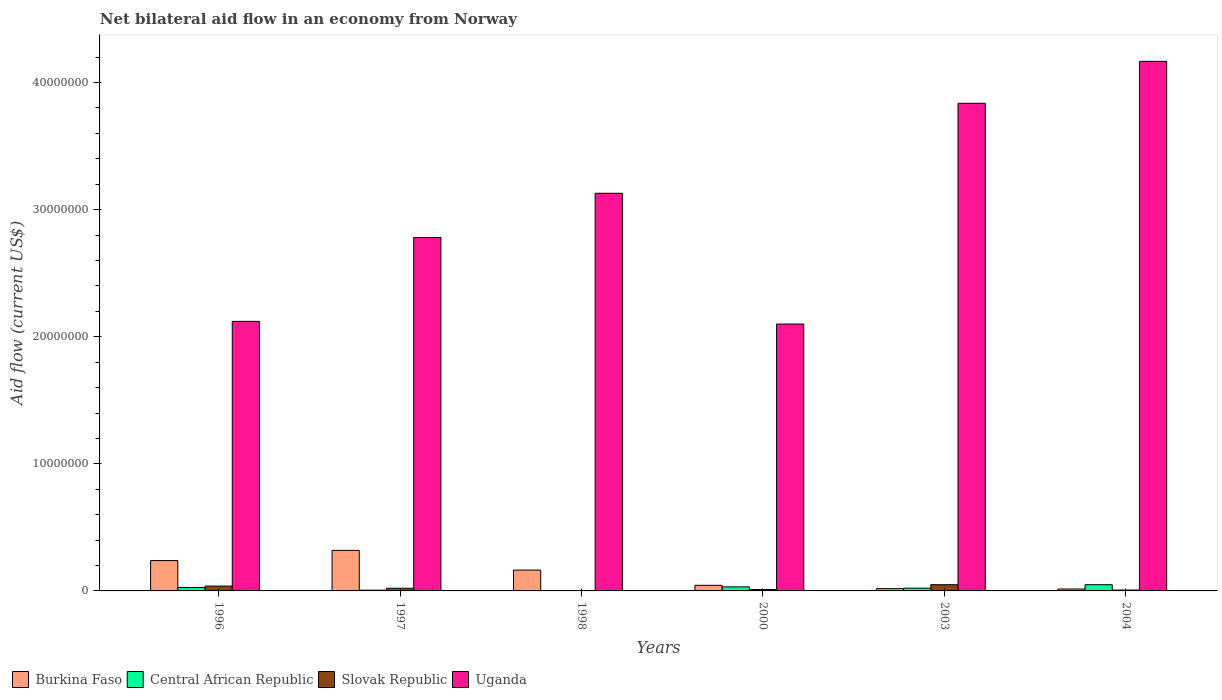How many bars are there on the 5th tick from the left?
Give a very brief answer. 4. What is the net bilateral aid flow in Central African Republic in 1997?
Provide a succinct answer. 6.00e+04. Across all years, what is the maximum net bilateral aid flow in Uganda?
Provide a succinct answer. 4.17e+07. In which year was the net bilateral aid flow in Central African Republic maximum?
Your answer should be very brief. 2004. What is the total net bilateral aid flow in Uganda in the graph?
Provide a succinct answer. 1.81e+08. What is the difference between the net bilateral aid flow in Slovak Republic in 1996 and that in 2003?
Ensure brevity in your answer.  -1.10e+05. What is the average net bilateral aid flow in Uganda per year?
Your answer should be compact. 3.02e+07. In the year 1998, what is the difference between the net bilateral aid flow in Uganda and net bilateral aid flow in Central African Republic?
Offer a terse response. 3.13e+07. In how many years, is the net bilateral aid flow in Central African Republic greater than 6000000 US$?
Your answer should be compact. 0. What is the ratio of the net bilateral aid flow in Uganda in 1997 to that in 2004?
Make the answer very short. 0.67. Is the net bilateral aid flow in Central African Republic in 1996 less than that in 2000?
Ensure brevity in your answer.  Yes. What is the difference between the highest and the lowest net bilateral aid flow in Burkina Faso?
Make the answer very short. 3.04e+06. In how many years, is the net bilateral aid flow in Burkina Faso greater than the average net bilateral aid flow in Burkina Faso taken over all years?
Ensure brevity in your answer.  3. What does the 3rd bar from the left in 1996 represents?
Offer a terse response. Slovak Republic. What does the 3rd bar from the right in 2000 represents?
Offer a terse response. Central African Republic. Are all the bars in the graph horizontal?
Ensure brevity in your answer.  No. What is the difference between two consecutive major ticks on the Y-axis?
Your answer should be compact. 1.00e+07. How many legend labels are there?
Provide a succinct answer. 4. How are the legend labels stacked?
Provide a succinct answer. Horizontal. What is the title of the graph?
Give a very brief answer. Net bilateral aid flow in an economy from Norway. What is the Aid flow (current US$) in Burkina Faso in 1996?
Offer a very short reply. 2.39e+06. What is the Aid flow (current US$) of Uganda in 1996?
Offer a very short reply. 2.12e+07. What is the Aid flow (current US$) of Burkina Faso in 1997?
Keep it short and to the point. 3.19e+06. What is the Aid flow (current US$) of Central African Republic in 1997?
Your answer should be compact. 6.00e+04. What is the Aid flow (current US$) in Uganda in 1997?
Ensure brevity in your answer.  2.78e+07. What is the Aid flow (current US$) in Burkina Faso in 1998?
Make the answer very short. 1.64e+06. What is the Aid flow (current US$) of Central African Republic in 1998?
Offer a very short reply. 2.00e+04. What is the Aid flow (current US$) in Uganda in 1998?
Keep it short and to the point. 3.13e+07. What is the Aid flow (current US$) of Burkina Faso in 2000?
Your response must be concise. 4.40e+05. What is the Aid flow (current US$) of Slovak Republic in 2000?
Make the answer very short. 1.10e+05. What is the Aid flow (current US$) of Uganda in 2000?
Give a very brief answer. 2.10e+07. What is the Aid flow (current US$) of Central African Republic in 2003?
Offer a terse response. 2.20e+05. What is the Aid flow (current US$) in Uganda in 2003?
Your answer should be compact. 3.84e+07. What is the Aid flow (current US$) of Uganda in 2004?
Provide a succinct answer. 4.17e+07. Across all years, what is the maximum Aid flow (current US$) of Burkina Faso?
Provide a short and direct response. 3.19e+06. Across all years, what is the maximum Aid flow (current US$) in Central African Republic?
Offer a terse response. 4.90e+05. Across all years, what is the maximum Aid flow (current US$) of Uganda?
Your response must be concise. 4.17e+07. Across all years, what is the minimum Aid flow (current US$) of Burkina Faso?
Give a very brief answer. 1.50e+05. Across all years, what is the minimum Aid flow (current US$) of Slovak Republic?
Your answer should be compact. 10000. Across all years, what is the minimum Aid flow (current US$) of Uganda?
Your response must be concise. 2.10e+07. What is the total Aid flow (current US$) in Burkina Faso in the graph?
Your response must be concise. 7.99e+06. What is the total Aid flow (current US$) of Central African Republic in the graph?
Make the answer very short. 1.38e+06. What is the total Aid flow (current US$) of Slovak Republic in the graph?
Make the answer very short. 1.27e+06. What is the total Aid flow (current US$) of Uganda in the graph?
Your response must be concise. 1.81e+08. What is the difference between the Aid flow (current US$) of Burkina Faso in 1996 and that in 1997?
Your response must be concise. -8.00e+05. What is the difference between the Aid flow (current US$) of Central African Republic in 1996 and that in 1997?
Your answer should be very brief. 2.10e+05. What is the difference between the Aid flow (current US$) in Slovak Republic in 1996 and that in 1997?
Offer a very short reply. 1.70e+05. What is the difference between the Aid flow (current US$) of Uganda in 1996 and that in 1997?
Give a very brief answer. -6.60e+06. What is the difference between the Aid flow (current US$) of Burkina Faso in 1996 and that in 1998?
Make the answer very short. 7.50e+05. What is the difference between the Aid flow (current US$) of Central African Republic in 1996 and that in 1998?
Keep it short and to the point. 2.50e+05. What is the difference between the Aid flow (current US$) in Slovak Republic in 1996 and that in 1998?
Offer a very short reply. 3.70e+05. What is the difference between the Aid flow (current US$) of Uganda in 1996 and that in 1998?
Offer a terse response. -1.01e+07. What is the difference between the Aid flow (current US$) of Burkina Faso in 1996 and that in 2000?
Make the answer very short. 1.95e+06. What is the difference between the Aid flow (current US$) in Central African Republic in 1996 and that in 2000?
Your answer should be very brief. -5.00e+04. What is the difference between the Aid flow (current US$) of Slovak Republic in 1996 and that in 2000?
Your answer should be compact. 2.70e+05. What is the difference between the Aid flow (current US$) of Burkina Faso in 1996 and that in 2003?
Offer a very short reply. 2.21e+06. What is the difference between the Aid flow (current US$) in Central African Republic in 1996 and that in 2003?
Make the answer very short. 5.00e+04. What is the difference between the Aid flow (current US$) of Slovak Republic in 1996 and that in 2003?
Keep it short and to the point. -1.10e+05. What is the difference between the Aid flow (current US$) in Uganda in 1996 and that in 2003?
Give a very brief answer. -1.72e+07. What is the difference between the Aid flow (current US$) in Burkina Faso in 1996 and that in 2004?
Your answer should be very brief. 2.24e+06. What is the difference between the Aid flow (current US$) in Central African Republic in 1996 and that in 2004?
Your answer should be very brief. -2.20e+05. What is the difference between the Aid flow (current US$) in Uganda in 1996 and that in 2004?
Your response must be concise. -2.05e+07. What is the difference between the Aid flow (current US$) in Burkina Faso in 1997 and that in 1998?
Your answer should be very brief. 1.55e+06. What is the difference between the Aid flow (current US$) of Central African Republic in 1997 and that in 1998?
Provide a short and direct response. 4.00e+04. What is the difference between the Aid flow (current US$) in Uganda in 1997 and that in 1998?
Provide a short and direct response. -3.48e+06. What is the difference between the Aid flow (current US$) in Burkina Faso in 1997 and that in 2000?
Ensure brevity in your answer.  2.75e+06. What is the difference between the Aid flow (current US$) of Central African Republic in 1997 and that in 2000?
Offer a terse response. -2.60e+05. What is the difference between the Aid flow (current US$) of Slovak Republic in 1997 and that in 2000?
Provide a short and direct response. 1.00e+05. What is the difference between the Aid flow (current US$) of Uganda in 1997 and that in 2000?
Your answer should be compact. 6.81e+06. What is the difference between the Aid flow (current US$) of Burkina Faso in 1997 and that in 2003?
Make the answer very short. 3.01e+06. What is the difference between the Aid flow (current US$) of Slovak Republic in 1997 and that in 2003?
Offer a very short reply. -2.80e+05. What is the difference between the Aid flow (current US$) in Uganda in 1997 and that in 2003?
Provide a short and direct response. -1.06e+07. What is the difference between the Aid flow (current US$) of Burkina Faso in 1997 and that in 2004?
Keep it short and to the point. 3.04e+06. What is the difference between the Aid flow (current US$) of Central African Republic in 1997 and that in 2004?
Ensure brevity in your answer.  -4.30e+05. What is the difference between the Aid flow (current US$) of Slovak Republic in 1997 and that in 2004?
Offer a terse response. 1.40e+05. What is the difference between the Aid flow (current US$) of Uganda in 1997 and that in 2004?
Offer a very short reply. -1.39e+07. What is the difference between the Aid flow (current US$) of Burkina Faso in 1998 and that in 2000?
Offer a terse response. 1.20e+06. What is the difference between the Aid flow (current US$) of Central African Republic in 1998 and that in 2000?
Offer a very short reply. -3.00e+05. What is the difference between the Aid flow (current US$) of Slovak Republic in 1998 and that in 2000?
Ensure brevity in your answer.  -1.00e+05. What is the difference between the Aid flow (current US$) of Uganda in 1998 and that in 2000?
Ensure brevity in your answer.  1.03e+07. What is the difference between the Aid flow (current US$) of Burkina Faso in 1998 and that in 2003?
Provide a short and direct response. 1.46e+06. What is the difference between the Aid flow (current US$) of Central African Republic in 1998 and that in 2003?
Your answer should be very brief. -2.00e+05. What is the difference between the Aid flow (current US$) of Slovak Republic in 1998 and that in 2003?
Provide a short and direct response. -4.80e+05. What is the difference between the Aid flow (current US$) of Uganda in 1998 and that in 2003?
Provide a succinct answer. -7.08e+06. What is the difference between the Aid flow (current US$) of Burkina Faso in 1998 and that in 2004?
Your answer should be compact. 1.49e+06. What is the difference between the Aid flow (current US$) of Central African Republic in 1998 and that in 2004?
Your response must be concise. -4.70e+05. What is the difference between the Aid flow (current US$) of Uganda in 1998 and that in 2004?
Your response must be concise. -1.04e+07. What is the difference between the Aid flow (current US$) in Slovak Republic in 2000 and that in 2003?
Offer a terse response. -3.80e+05. What is the difference between the Aid flow (current US$) in Uganda in 2000 and that in 2003?
Your response must be concise. -1.74e+07. What is the difference between the Aid flow (current US$) of Central African Republic in 2000 and that in 2004?
Give a very brief answer. -1.70e+05. What is the difference between the Aid flow (current US$) in Uganda in 2000 and that in 2004?
Keep it short and to the point. -2.07e+07. What is the difference between the Aid flow (current US$) of Burkina Faso in 2003 and that in 2004?
Ensure brevity in your answer.  3.00e+04. What is the difference between the Aid flow (current US$) in Uganda in 2003 and that in 2004?
Your answer should be very brief. -3.30e+06. What is the difference between the Aid flow (current US$) in Burkina Faso in 1996 and the Aid flow (current US$) in Central African Republic in 1997?
Ensure brevity in your answer.  2.33e+06. What is the difference between the Aid flow (current US$) of Burkina Faso in 1996 and the Aid flow (current US$) of Slovak Republic in 1997?
Provide a succinct answer. 2.18e+06. What is the difference between the Aid flow (current US$) in Burkina Faso in 1996 and the Aid flow (current US$) in Uganda in 1997?
Give a very brief answer. -2.54e+07. What is the difference between the Aid flow (current US$) of Central African Republic in 1996 and the Aid flow (current US$) of Slovak Republic in 1997?
Ensure brevity in your answer.  6.00e+04. What is the difference between the Aid flow (current US$) in Central African Republic in 1996 and the Aid flow (current US$) in Uganda in 1997?
Make the answer very short. -2.75e+07. What is the difference between the Aid flow (current US$) of Slovak Republic in 1996 and the Aid flow (current US$) of Uganda in 1997?
Make the answer very short. -2.74e+07. What is the difference between the Aid flow (current US$) in Burkina Faso in 1996 and the Aid flow (current US$) in Central African Republic in 1998?
Give a very brief answer. 2.37e+06. What is the difference between the Aid flow (current US$) of Burkina Faso in 1996 and the Aid flow (current US$) of Slovak Republic in 1998?
Give a very brief answer. 2.38e+06. What is the difference between the Aid flow (current US$) of Burkina Faso in 1996 and the Aid flow (current US$) of Uganda in 1998?
Give a very brief answer. -2.89e+07. What is the difference between the Aid flow (current US$) of Central African Republic in 1996 and the Aid flow (current US$) of Uganda in 1998?
Your answer should be compact. -3.10e+07. What is the difference between the Aid flow (current US$) in Slovak Republic in 1996 and the Aid flow (current US$) in Uganda in 1998?
Your answer should be compact. -3.09e+07. What is the difference between the Aid flow (current US$) in Burkina Faso in 1996 and the Aid flow (current US$) in Central African Republic in 2000?
Ensure brevity in your answer.  2.07e+06. What is the difference between the Aid flow (current US$) of Burkina Faso in 1996 and the Aid flow (current US$) of Slovak Republic in 2000?
Keep it short and to the point. 2.28e+06. What is the difference between the Aid flow (current US$) in Burkina Faso in 1996 and the Aid flow (current US$) in Uganda in 2000?
Your response must be concise. -1.86e+07. What is the difference between the Aid flow (current US$) of Central African Republic in 1996 and the Aid flow (current US$) of Slovak Republic in 2000?
Provide a short and direct response. 1.60e+05. What is the difference between the Aid flow (current US$) in Central African Republic in 1996 and the Aid flow (current US$) in Uganda in 2000?
Keep it short and to the point. -2.07e+07. What is the difference between the Aid flow (current US$) of Slovak Republic in 1996 and the Aid flow (current US$) of Uganda in 2000?
Offer a terse response. -2.06e+07. What is the difference between the Aid flow (current US$) in Burkina Faso in 1996 and the Aid flow (current US$) in Central African Republic in 2003?
Make the answer very short. 2.17e+06. What is the difference between the Aid flow (current US$) of Burkina Faso in 1996 and the Aid flow (current US$) of Slovak Republic in 2003?
Keep it short and to the point. 1.90e+06. What is the difference between the Aid flow (current US$) of Burkina Faso in 1996 and the Aid flow (current US$) of Uganda in 2003?
Ensure brevity in your answer.  -3.60e+07. What is the difference between the Aid flow (current US$) of Central African Republic in 1996 and the Aid flow (current US$) of Uganda in 2003?
Your response must be concise. -3.81e+07. What is the difference between the Aid flow (current US$) of Slovak Republic in 1996 and the Aid flow (current US$) of Uganda in 2003?
Make the answer very short. -3.80e+07. What is the difference between the Aid flow (current US$) in Burkina Faso in 1996 and the Aid flow (current US$) in Central African Republic in 2004?
Provide a succinct answer. 1.90e+06. What is the difference between the Aid flow (current US$) of Burkina Faso in 1996 and the Aid flow (current US$) of Slovak Republic in 2004?
Your answer should be very brief. 2.32e+06. What is the difference between the Aid flow (current US$) of Burkina Faso in 1996 and the Aid flow (current US$) of Uganda in 2004?
Your answer should be very brief. -3.93e+07. What is the difference between the Aid flow (current US$) of Central African Republic in 1996 and the Aid flow (current US$) of Slovak Republic in 2004?
Give a very brief answer. 2.00e+05. What is the difference between the Aid flow (current US$) in Central African Republic in 1996 and the Aid flow (current US$) in Uganda in 2004?
Ensure brevity in your answer.  -4.14e+07. What is the difference between the Aid flow (current US$) in Slovak Republic in 1996 and the Aid flow (current US$) in Uganda in 2004?
Provide a short and direct response. -4.13e+07. What is the difference between the Aid flow (current US$) of Burkina Faso in 1997 and the Aid flow (current US$) of Central African Republic in 1998?
Your response must be concise. 3.17e+06. What is the difference between the Aid flow (current US$) of Burkina Faso in 1997 and the Aid flow (current US$) of Slovak Republic in 1998?
Keep it short and to the point. 3.18e+06. What is the difference between the Aid flow (current US$) in Burkina Faso in 1997 and the Aid flow (current US$) in Uganda in 1998?
Give a very brief answer. -2.81e+07. What is the difference between the Aid flow (current US$) of Central African Republic in 1997 and the Aid flow (current US$) of Slovak Republic in 1998?
Ensure brevity in your answer.  5.00e+04. What is the difference between the Aid flow (current US$) in Central African Republic in 1997 and the Aid flow (current US$) in Uganda in 1998?
Your answer should be very brief. -3.12e+07. What is the difference between the Aid flow (current US$) in Slovak Republic in 1997 and the Aid flow (current US$) in Uganda in 1998?
Make the answer very short. -3.11e+07. What is the difference between the Aid flow (current US$) in Burkina Faso in 1997 and the Aid flow (current US$) in Central African Republic in 2000?
Your answer should be very brief. 2.87e+06. What is the difference between the Aid flow (current US$) of Burkina Faso in 1997 and the Aid flow (current US$) of Slovak Republic in 2000?
Your answer should be very brief. 3.08e+06. What is the difference between the Aid flow (current US$) in Burkina Faso in 1997 and the Aid flow (current US$) in Uganda in 2000?
Your answer should be very brief. -1.78e+07. What is the difference between the Aid flow (current US$) in Central African Republic in 1997 and the Aid flow (current US$) in Slovak Republic in 2000?
Your answer should be compact. -5.00e+04. What is the difference between the Aid flow (current US$) in Central African Republic in 1997 and the Aid flow (current US$) in Uganda in 2000?
Your answer should be very brief. -2.09e+07. What is the difference between the Aid flow (current US$) in Slovak Republic in 1997 and the Aid flow (current US$) in Uganda in 2000?
Your answer should be very brief. -2.08e+07. What is the difference between the Aid flow (current US$) in Burkina Faso in 1997 and the Aid flow (current US$) in Central African Republic in 2003?
Offer a terse response. 2.97e+06. What is the difference between the Aid flow (current US$) of Burkina Faso in 1997 and the Aid flow (current US$) of Slovak Republic in 2003?
Make the answer very short. 2.70e+06. What is the difference between the Aid flow (current US$) in Burkina Faso in 1997 and the Aid flow (current US$) in Uganda in 2003?
Provide a short and direct response. -3.52e+07. What is the difference between the Aid flow (current US$) in Central African Republic in 1997 and the Aid flow (current US$) in Slovak Republic in 2003?
Your response must be concise. -4.30e+05. What is the difference between the Aid flow (current US$) of Central African Republic in 1997 and the Aid flow (current US$) of Uganda in 2003?
Your answer should be compact. -3.83e+07. What is the difference between the Aid flow (current US$) of Slovak Republic in 1997 and the Aid flow (current US$) of Uganda in 2003?
Make the answer very short. -3.82e+07. What is the difference between the Aid flow (current US$) in Burkina Faso in 1997 and the Aid flow (current US$) in Central African Republic in 2004?
Your response must be concise. 2.70e+06. What is the difference between the Aid flow (current US$) in Burkina Faso in 1997 and the Aid flow (current US$) in Slovak Republic in 2004?
Offer a very short reply. 3.12e+06. What is the difference between the Aid flow (current US$) in Burkina Faso in 1997 and the Aid flow (current US$) in Uganda in 2004?
Ensure brevity in your answer.  -3.85e+07. What is the difference between the Aid flow (current US$) of Central African Republic in 1997 and the Aid flow (current US$) of Uganda in 2004?
Offer a very short reply. -4.16e+07. What is the difference between the Aid flow (current US$) of Slovak Republic in 1997 and the Aid flow (current US$) of Uganda in 2004?
Your answer should be compact. -4.15e+07. What is the difference between the Aid flow (current US$) in Burkina Faso in 1998 and the Aid flow (current US$) in Central African Republic in 2000?
Your response must be concise. 1.32e+06. What is the difference between the Aid flow (current US$) of Burkina Faso in 1998 and the Aid flow (current US$) of Slovak Republic in 2000?
Your answer should be compact. 1.53e+06. What is the difference between the Aid flow (current US$) in Burkina Faso in 1998 and the Aid flow (current US$) in Uganda in 2000?
Give a very brief answer. -1.94e+07. What is the difference between the Aid flow (current US$) in Central African Republic in 1998 and the Aid flow (current US$) in Uganda in 2000?
Your answer should be very brief. -2.10e+07. What is the difference between the Aid flow (current US$) in Slovak Republic in 1998 and the Aid flow (current US$) in Uganda in 2000?
Offer a terse response. -2.10e+07. What is the difference between the Aid flow (current US$) of Burkina Faso in 1998 and the Aid flow (current US$) of Central African Republic in 2003?
Offer a terse response. 1.42e+06. What is the difference between the Aid flow (current US$) in Burkina Faso in 1998 and the Aid flow (current US$) in Slovak Republic in 2003?
Offer a very short reply. 1.15e+06. What is the difference between the Aid flow (current US$) in Burkina Faso in 1998 and the Aid flow (current US$) in Uganda in 2003?
Provide a succinct answer. -3.67e+07. What is the difference between the Aid flow (current US$) of Central African Republic in 1998 and the Aid flow (current US$) of Slovak Republic in 2003?
Your answer should be compact. -4.70e+05. What is the difference between the Aid flow (current US$) of Central African Republic in 1998 and the Aid flow (current US$) of Uganda in 2003?
Make the answer very short. -3.84e+07. What is the difference between the Aid flow (current US$) in Slovak Republic in 1998 and the Aid flow (current US$) in Uganda in 2003?
Ensure brevity in your answer.  -3.84e+07. What is the difference between the Aid flow (current US$) of Burkina Faso in 1998 and the Aid flow (current US$) of Central African Republic in 2004?
Your response must be concise. 1.15e+06. What is the difference between the Aid flow (current US$) in Burkina Faso in 1998 and the Aid flow (current US$) in Slovak Republic in 2004?
Make the answer very short. 1.57e+06. What is the difference between the Aid flow (current US$) in Burkina Faso in 1998 and the Aid flow (current US$) in Uganda in 2004?
Offer a terse response. -4.00e+07. What is the difference between the Aid flow (current US$) in Central African Republic in 1998 and the Aid flow (current US$) in Slovak Republic in 2004?
Offer a very short reply. -5.00e+04. What is the difference between the Aid flow (current US$) of Central African Republic in 1998 and the Aid flow (current US$) of Uganda in 2004?
Offer a terse response. -4.16e+07. What is the difference between the Aid flow (current US$) in Slovak Republic in 1998 and the Aid flow (current US$) in Uganda in 2004?
Your answer should be compact. -4.17e+07. What is the difference between the Aid flow (current US$) in Burkina Faso in 2000 and the Aid flow (current US$) in Central African Republic in 2003?
Provide a short and direct response. 2.20e+05. What is the difference between the Aid flow (current US$) of Burkina Faso in 2000 and the Aid flow (current US$) of Slovak Republic in 2003?
Your response must be concise. -5.00e+04. What is the difference between the Aid flow (current US$) of Burkina Faso in 2000 and the Aid flow (current US$) of Uganda in 2003?
Your response must be concise. -3.79e+07. What is the difference between the Aid flow (current US$) in Central African Republic in 2000 and the Aid flow (current US$) in Slovak Republic in 2003?
Keep it short and to the point. -1.70e+05. What is the difference between the Aid flow (current US$) of Central African Republic in 2000 and the Aid flow (current US$) of Uganda in 2003?
Make the answer very short. -3.80e+07. What is the difference between the Aid flow (current US$) of Slovak Republic in 2000 and the Aid flow (current US$) of Uganda in 2003?
Give a very brief answer. -3.83e+07. What is the difference between the Aid flow (current US$) of Burkina Faso in 2000 and the Aid flow (current US$) of Central African Republic in 2004?
Offer a very short reply. -5.00e+04. What is the difference between the Aid flow (current US$) in Burkina Faso in 2000 and the Aid flow (current US$) in Slovak Republic in 2004?
Your response must be concise. 3.70e+05. What is the difference between the Aid flow (current US$) in Burkina Faso in 2000 and the Aid flow (current US$) in Uganda in 2004?
Your answer should be compact. -4.12e+07. What is the difference between the Aid flow (current US$) of Central African Republic in 2000 and the Aid flow (current US$) of Uganda in 2004?
Offer a terse response. -4.14e+07. What is the difference between the Aid flow (current US$) in Slovak Republic in 2000 and the Aid flow (current US$) in Uganda in 2004?
Your response must be concise. -4.16e+07. What is the difference between the Aid flow (current US$) in Burkina Faso in 2003 and the Aid flow (current US$) in Central African Republic in 2004?
Make the answer very short. -3.10e+05. What is the difference between the Aid flow (current US$) of Burkina Faso in 2003 and the Aid flow (current US$) of Uganda in 2004?
Offer a terse response. -4.15e+07. What is the difference between the Aid flow (current US$) in Central African Republic in 2003 and the Aid flow (current US$) in Uganda in 2004?
Make the answer very short. -4.14e+07. What is the difference between the Aid flow (current US$) in Slovak Republic in 2003 and the Aid flow (current US$) in Uganda in 2004?
Your answer should be compact. -4.12e+07. What is the average Aid flow (current US$) of Burkina Faso per year?
Provide a short and direct response. 1.33e+06. What is the average Aid flow (current US$) in Central African Republic per year?
Ensure brevity in your answer.  2.30e+05. What is the average Aid flow (current US$) in Slovak Republic per year?
Keep it short and to the point. 2.12e+05. What is the average Aid flow (current US$) in Uganda per year?
Your answer should be compact. 3.02e+07. In the year 1996, what is the difference between the Aid flow (current US$) in Burkina Faso and Aid flow (current US$) in Central African Republic?
Your answer should be very brief. 2.12e+06. In the year 1996, what is the difference between the Aid flow (current US$) in Burkina Faso and Aid flow (current US$) in Slovak Republic?
Give a very brief answer. 2.01e+06. In the year 1996, what is the difference between the Aid flow (current US$) in Burkina Faso and Aid flow (current US$) in Uganda?
Keep it short and to the point. -1.88e+07. In the year 1996, what is the difference between the Aid flow (current US$) in Central African Republic and Aid flow (current US$) in Uganda?
Your answer should be very brief. -2.09e+07. In the year 1996, what is the difference between the Aid flow (current US$) in Slovak Republic and Aid flow (current US$) in Uganda?
Offer a very short reply. -2.08e+07. In the year 1997, what is the difference between the Aid flow (current US$) of Burkina Faso and Aid flow (current US$) of Central African Republic?
Ensure brevity in your answer.  3.13e+06. In the year 1997, what is the difference between the Aid flow (current US$) in Burkina Faso and Aid flow (current US$) in Slovak Republic?
Provide a short and direct response. 2.98e+06. In the year 1997, what is the difference between the Aid flow (current US$) of Burkina Faso and Aid flow (current US$) of Uganda?
Your response must be concise. -2.46e+07. In the year 1997, what is the difference between the Aid flow (current US$) of Central African Republic and Aid flow (current US$) of Slovak Republic?
Make the answer very short. -1.50e+05. In the year 1997, what is the difference between the Aid flow (current US$) of Central African Republic and Aid flow (current US$) of Uganda?
Your answer should be compact. -2.78e+07. In the year 1997, what is the difference between the Aid flow (current US$) of Slovak Republic and Aid flow (current US$) of Uganda?
Offer a very short reply. -2.76e+07. In the year 1998, what is the difference between the Aid flow (current US$) in Burkina Faso and Aid flow (current US$) in Central African Republic?
Provide a succinct answer. 1.62e+06. In the year 1998, what is the difference between the Aid flow (current US$) in Burkina Faso and Aid flow (current US$) in Slovak Republic?
Give a very brief answer. 1.63e+06. In the year 1998, what is the difference between the Aid flow (current US$) in Burkina Faso and Aid flow (current US$) in Uganda?
Ensure brevity in your answer.  -2.96e+07. In the year 1998, what is the difference between the Aid flow (current US$) of Central African Republic and Aid flow (current US$) of Slovak Republic?
Make the answer very short. 10000. In the year 1998, what is the difference between the Aid flow (current US$) of Central African Republic and Aid flow (current US$) of Uganda?
Offer a very short reply. -3.13e+07. In the year 1998, what is the difference between the Aid flow (current US$) in Slovak Republic and Aid flow (current US$) in Uganda?
Your response must be concise. -3.13e+07. In the year 2000, what is the difference between the Aid flow (current US$) in Burkina Faso and Aid flow (current US$) in Central African Republic?
Offer a very short reply. 1.20e+05. In the year 2000, what is the difference between the Aid flow (current US$) in Burkina Faso and Aid flow (current US$) in Uganda?
Provide a succinct answer. -2.06e+07. In the year 2000, what is the difference between the Aid flow (current US$) in Central African Republic and Aid flow (current US$) in Slovak Republic?
Provide a short and direct response. 2.10e+05. In the year 2000, what is the difference between the Aid flow (current US$) of Central African Republic and Aid flow (current US$) of Uganda?
Your answer should be very brief. -2.07e+07. In the year 2000, what is the difference between the Aid flow (current US$) of Slovak Republic and Aid flow (current US$) of Uganda?
Offer a terse response. -2.09e+07. In the year 2003, what is the difference between the Aid flow (current US$) in Burkina Faso and Aid flow (current US$) in Central African Republic?
Provide a short and direct response. -4.00e+04. In the year 2003, what is the difference between the Aid flow (current US$) in Burkina Faso and Aid flow (current US$) in Slovak Republic?
Ensure brevity in your answer.  -3.10e+05. In the year 2003, what is the difference between the Aid flow (current US$) in Burkina Faso and Aid flow (current US$) in Uganda?
Give a very brief answer. -3.82e+07. In the year 2003, what is the difference between the Aid flow (current US$) in Central African Republic and Aid flow (current US$) in Uganda?
Offer a terse response. -3.82e+07. In the year 2003, what is the difference between the Aid flow (current US$) of Slovak Republic and Aid flow (current US$) of Uganda?
Your response must be concise. -3.79e+07. In the year 2004, what is the difference between the Aid flow (current US$) in Burkina Faso and Aid flow (current US$) in Slovak Republic?
Ensure brevity in your answer.  8.00e+04. In the year 2004, what is the difference between the Aid flow (current US$) of Burkina Faso and Aid flow (current US$) of Uganda?
Your answer should be compact. -4.15e+07. In the year 2004, what is the difference between the Aid flow (current US$) of Central African Republic and Aid flow (current US$) of Slovak Republic?
Ensure brevity in your answer.  4.20e+05. In the year 2004, what is the difference between the Aid flow (current US$) of Central African Republic and Aid flow (current US$) of Uganda?
Offer a terse response. -4.12e+07. In the year 2004, what is the difference between the Aid flow (current US$) in Slovak Republic and Aid flow (current US$) in Uganda?
Make the answer very short. -4.16e+07. What is the ratio of the Aid flow (current US$) in Burkina Faso in 1996 to that in 1997?
Your response must be concise. 0.75. What is the ratio of the Aid flow (current US$) of Slovak Republic in 1996 to that in 1997?
Offer a very short reply. 1.81. What is the ratio of the Aid flow (current US$) in Uganda in 1996 to that in 1997?
Your answer should be compact. 0.76. What is the ratio of the Aid flow (current US$) in Burkina Faso in 1996 to that in 1998?
Keep it short and to the point. 1.46. What is the ratio of the Aid flow (current US$) in Uganda in 1996 to that in 1998?
Ensure brevity in your answer.  0.68. What is the ratio of the Aid flow (current US$) in Burkina Faso in 1996 to that in 2000?
Offer a very short reply. 5.43. What is the ratio of the Aid flow (current US$) in Central African Republic in 1996 to that in 2000?
Provide a short and direct response. 0.84. What is the ratio of the Aid flow (current US$) of Slovak Republic in 1996 to that in 2000?
Provide a succinct answer. 3.45. What is the ratio of the Aid flow (current US$) in Burkina Faso in 1996 to that in 2003?
Ensure brevity in your answer.  13.28. What is the ratio of the Aid flow (current US$) of Central African Republic in 1996 to that in 2003?
Your answer should be compact. 1.23. What is the ratio of the Aid flow (current US$) in Slovak Republic in 1996 to that in 2003?
Offer a very short reply. 0.78. What is the ratio of the Aid flow (current US$) of Uganda in 1996 to that in 2003?
Give a very brief answer. 0.55. What is the ratio of the Aid flow (current US$) of Burkina Faso in 1996 to that in 2004?
Your response must be concise. 15.93. What is the ratio of the Aid flow (current US$) of Central African Republic in 1996 to that in 2004?
Ensure brevity in your answer.  0.55. What is the ratio of the Aid flow (current US$) of Slovak Republic in 1996 to that in 2004?
Keep it short and to the point. 5.43. What is the ratio of the Aid flow (current US$) of Uganda in 1996 to that in 2004?
Your answer should be very brief. 0.51. What is the ratio of the Aid flow (current US$) in Burkina Faso in 1997 to that in 1998?
Your answer should be very brief. 1.95. What is the ratio of the Aid flow (current US$) in Central African Republic in 1997 to that in 1998?
Provide a succinct answer. 3. What is the ratio of the Aid flow (current US$) in Uganda in 1997 to that in 1998?
Your response must be concise. 0.89. What is the ratio of the Aid flow (current US$) of Burkina Faso in 1997 to that in 2000?
Make the answer very short. 7.25. What is the ratio of the Aid flow (current US$) of Central African Republic in 1997 to that in 2000?
Offer a terse response. 0.19. What is the ratio of the Aid flow (current US$) of Slovak Republic in 1997 to that in 2000?
Ensure brevity in your answer.  1.91. What is the ratio of the Aid flow (current US$) in Uganda in 1997 to that in 2000?
Offer a terse response. 1.32. What is the ratio of the Aid flow (current US$) of Burkina Faso in 1997 to that in 2003?
Keep it short and to the point. 17.72. What is the ratio of the Aid flow (current US$) of Central African Republic in 1997 to that in 2003?
Offer a very short reply. 0.27. What is the ratio of the Aid flow (current US$) in Slovak Republic in 1997 to that in 2003?
Provide a succinct answer. 0.43. What is the ratio of the Aid flow (current US$) in Uganda in 1997 to that in 2003?
Your answer should be very brief. 0.72. What is the ratio of the Aid flow (current US$) of Burkina Faso in 1997 to that in 2004?
Make the answer very short. 21.27. What is the ratio of the Aid flow (current US$) in Central African Republic in 1997 to that in 2004?
Ensure brevity in your answer.  0.12. What is the ratio of the Aid flow (current US$) in Slovak Republic in 1997 to that in 2004?
Offer a very short reply. 3. What is the ratio of the Aid flow (current US$) in Uganda in 1997 to that in 2004?
Provide a short and direct response. 0.67. What is the ratio of the Aid flow (current US$) of Burkina Faso in 1998 to that in 2000?
Give a very brief answer. 3.73. What is the ratio of the Aid flow (current US$) of Central African Republic in 1998 to that in 2000?
Provide a short and direct response. 0.06. What is the ratio of the Aid flow (current US$) in Slovak Republic in 1998 to that in 2000?
Your answer should be compact. 0.09. What is the ratio of the Aid flow (current US$) of Uganda in 1998 to that in 2000?
Your answer should be compact. 1.49. What is the ratio of the Aid flow (current US$) in Burkina Faso in 1998 to that in 2003?
Your answer should be very brief. 9.11. What is the ratio of the Aid flow (current US$) in Central African Republic in 1998 to that in 2003?
Provide a short and direct response. 0.09. What is the ratio of the Aid flow (current US$) of Slovak Republic in 1998 to that in 2003?
Provide a short and direct response. 0.02. What is the ratio of the Aid flow (current US$) of Uganda in 1998 to that in 2003?
Offer a terse response. 0.82. What is the ratio of the Aid flow (current US$) of Burkina Faso in 1998 to that in 2004?
Provide a short and direct response. 10.93. What is the ratio of the Aid flow (current US$) of Central African Republic in 1998 to that in 2004?
Make the answer very short. 0.04. What is the ratio of the Aid flow (current US$) in Slovak Republic in 1998 to that in 2004?
Make the answer very short. 0.14. What is the ratio of the Aid flow (current US$) of Uganda in 1998 to that in 2004?
Your answer should be compact. 0.75. What is the ratio of the Aid flow (current US$) in Burkina Faso in 2000 to that in 2003?
Offer a terse response. 2.44. What is the ratio of the Aid flow (current US$) in Central African Republic in 2000 to that in 2003?
Your answer should be compact. 1.45. What is the ratio of the Aid flow (current US$) in Slovak Republic in 2000 to that in 2003?
Offer a very short reply. 0.22. What is the ratio of the Aid flow (current US$) in Uganda in 2000 to that in 2003?
Your answer should be compact. 0.55. What is the ratio of the Aid flow (current US$) of Burkina Faso in 2000 to that in 2004?
Your answer should be very brief. 2.93. What is the ratio of the Aid flow (current US$) in Central African Republic in 2000 to that in 2004?
Give a very brief answer. 0.65. What is the ratio of the Aid flow (current US$) in Slovak Republic in 2000 to that in 2004?
Make the answer very short. 1.57. What is the ratio of the Aid flow (current US$) of Uganda in 2000 to that in 2004?
Offer a very short reply. 0.5. What is the ratio of the Aid flow (current US$) in Central African Republic in 2003 to that in 2004?
Your answer should be very brief. 0.45. What is the ratio of the Aid flow (current US$) of Slovak Republic in 2003 to that in 2004?
Keep it short and to the point. 7. What is the ratio of the Aid flow (current US$) of Uganda in 2003 to that in 2004?
Provide a succinct answer. 0.92. What is the difference between the highest and the second highest Aid flow (current US$) in Central African Republic?
Your answer should be compact. 1.70e+05. What is the difference between the highest and the second highest Aid flow (current US$) of Slovak Republic?
Your response must be concise. 1.10e+05. What is the difference between the highest and the second highest Aid flow (current US$) of Uganda?
Your response must be concise. 3.30e+06. What is the difference between the highest and the lowest Aid flow (current US$) in Burkina Faso?
Ensure brevity in your answer.  3.04e+06. What is the difference between the highest and the lowest Aid flow (current US$) in Uganda?
Offer a terse response. 2.07e+07. 